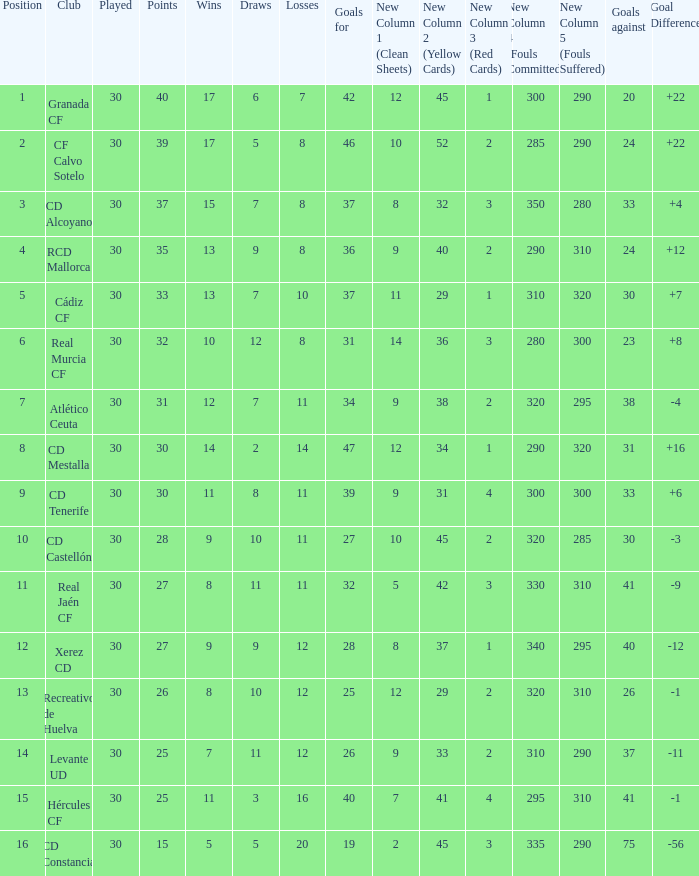Which Played has a Club of atlético ceuta, and less than 11 Losses? None. 